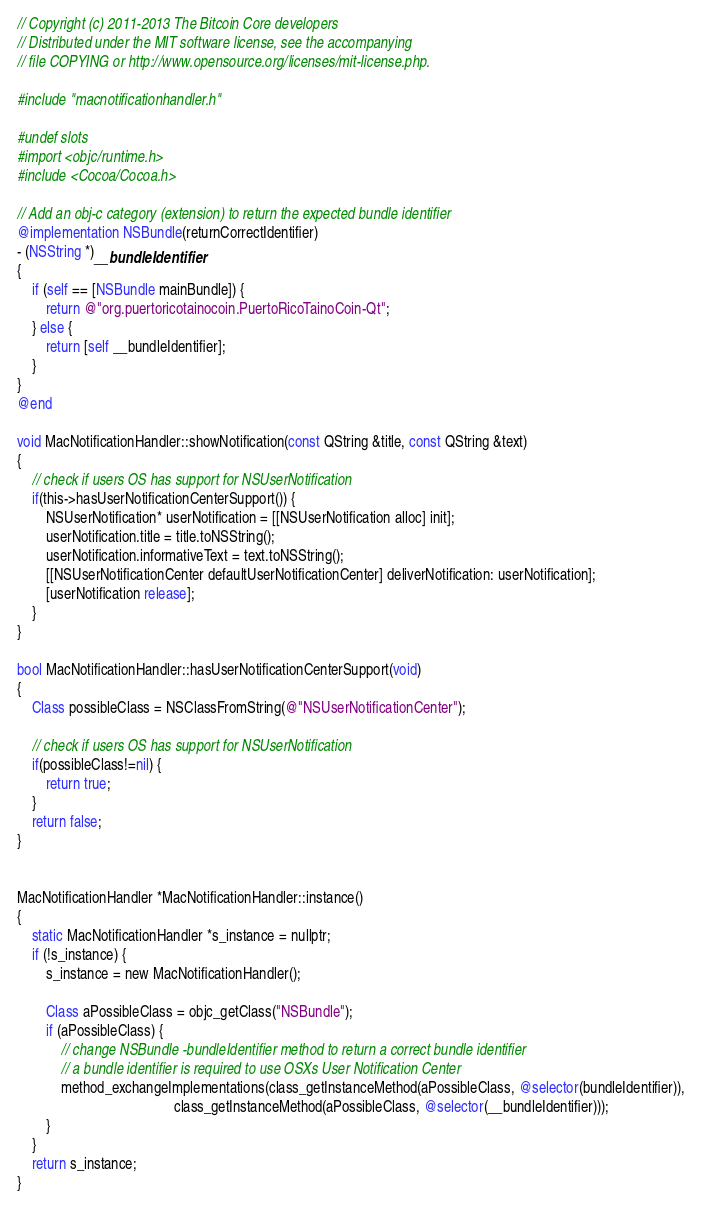Convert code to text. <code><loc_0><loc_0><loc_500><loc_500><_ObjectiveC_>// Copyright (c) 2011-2013 The Bitcoin Core developers
// Distributed under the MIT software license, see the accompanying
// file COPYING or http://www.opensource.org/licenses/mit-license.php.

#include "macnotificationhandler.h"

#undef slots
#import <objc/runtime.h>
#include <Cocoa/Cocoa.h>

// Add an obj-c category (extension) to return the expected bundle identifier
@implementation NSBundle(returnCorrectIdentifier)
- (NSString *)__bundleIdentifier
{
    if (self == [NSBundle mainBundle]) {
        return @"org.puertoricotainocoin.PuertoRicoTainoCoin-Qt";
    } else {
        return [self __bundleIdentifier];
    }
}
@end

void MacNotificationHandler::showNotification(const QString &title, const QString &text)
{
    // check if users OS has support for NSUserNotification
    if(this->hasUserNotificationCenterSupport()) {
        NSUserNotification* userNotification = [[NSUserNotification alloc] init];
        userNotification.title = title.toNSString();
        userNotification.informativeText = text.toNSString();
        [[NSUserNotificationCenter defaultUserNotificationCenter] deliverNotification: userNotification];
        [userNotification release];
    }
}

bool MacNotificationHandler::hasUserNotificationCenterSupport(void)
{
    Class possibleClass = NSClassFromString(@"NSUserNotificationCenter");

    // check if users OS has support for NSUserNotification
    if(possibleClass!=nil) {
        return true;
    }
    return false;
}


MacNotificationHandler *MacNotificationHandler::instance()
{
    static MacNotificationHandler *s_instance = nullptr;
    if (!s_instance) {
        s_instance = new MacNotificationHandler();

        Class aPossibleClass = objc_getClass("NSBundle");
        if (aPossibleClass) {
            // change NSBundle -bundleIdentifier method to return a correct bundle identifier
            // a bundle identifier is required to use OSXs User Notification Center
            method_exchangeImplementations(class_getInstanceMethod(aPossibleClass, @selector(bundleIdentifier)),
                                           class_getInstanceMethod(aPossibleClass, @selector(__bundleIdentifier)));
        }
    }
    return s_instance;
}
</code> 